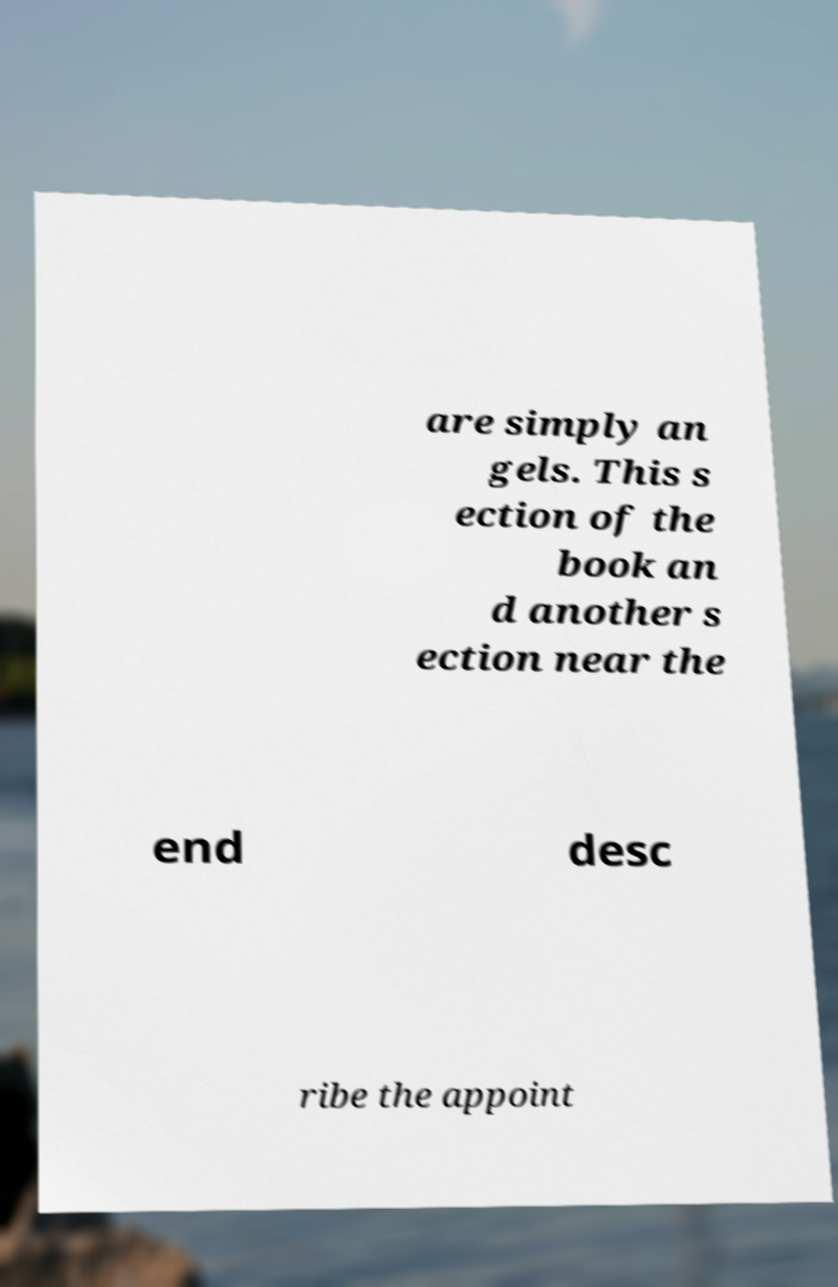I need the written content from this picture converted into text. Can you do that? are simply an gels. This s ection of the book an d another s ection near the end desc ribe the appoint 